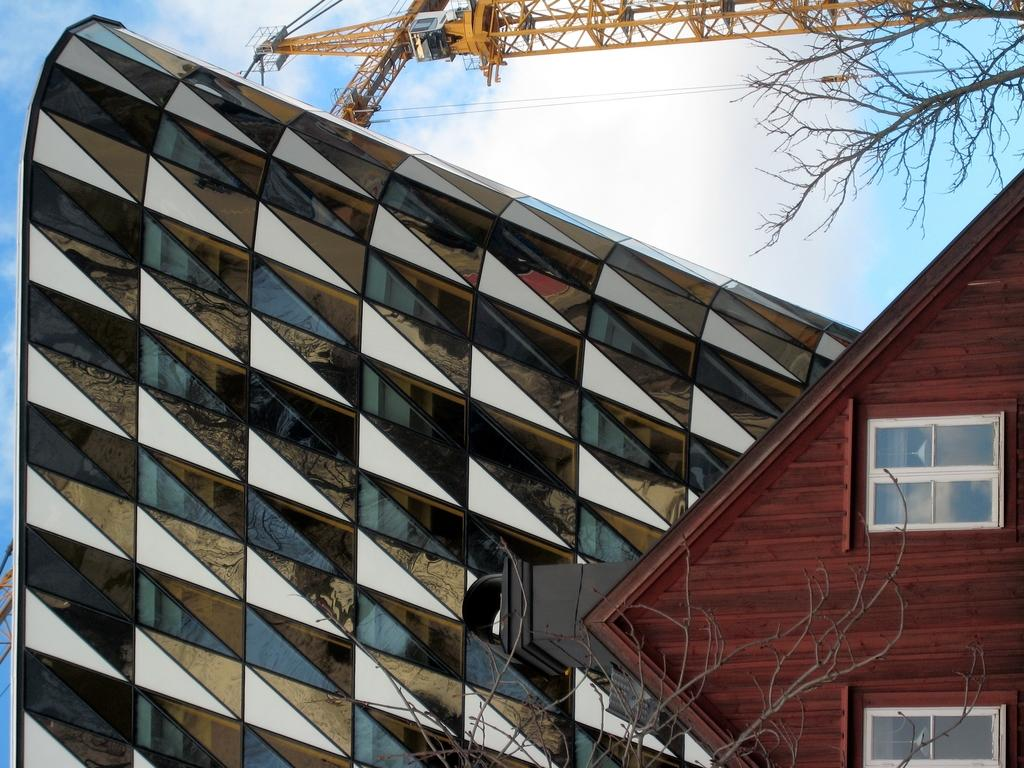What type of structure can be seen in the image? There is a house and a building in the image. What other elements are present in the image? There are trees and a crane in the image. What is the condition of the sky in the image? The sky is blue and cloudy in the image. How many basketballs can be seen in the image? There are no basketballs present in the image. What type of gate is visible in the image? There is no gate visible in the image. 